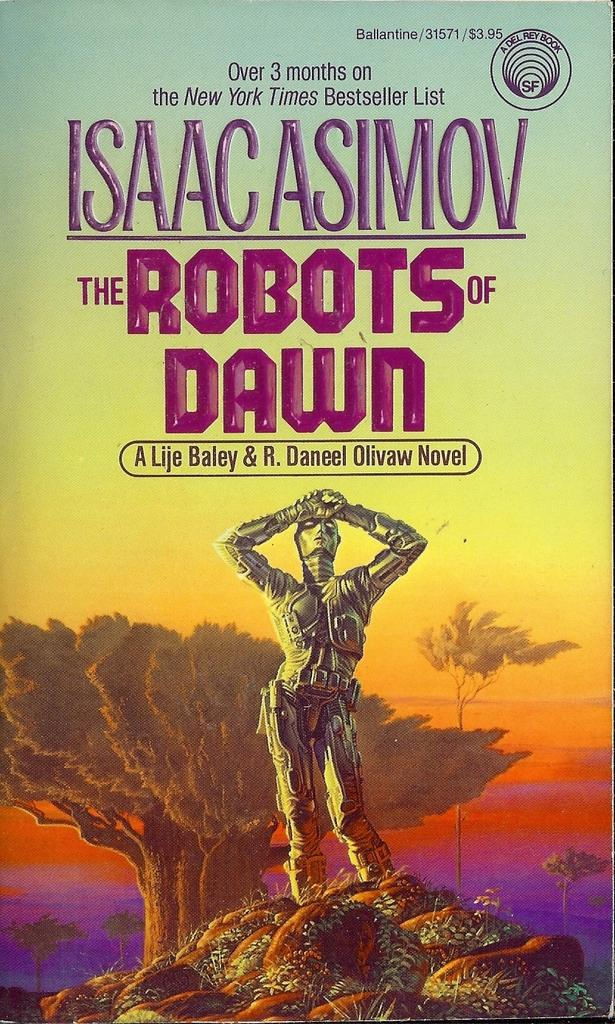<image>
Provide a brief description of the given image. The Isaac Asimov book called The Robots of Dawn has a robot character on the cover. 